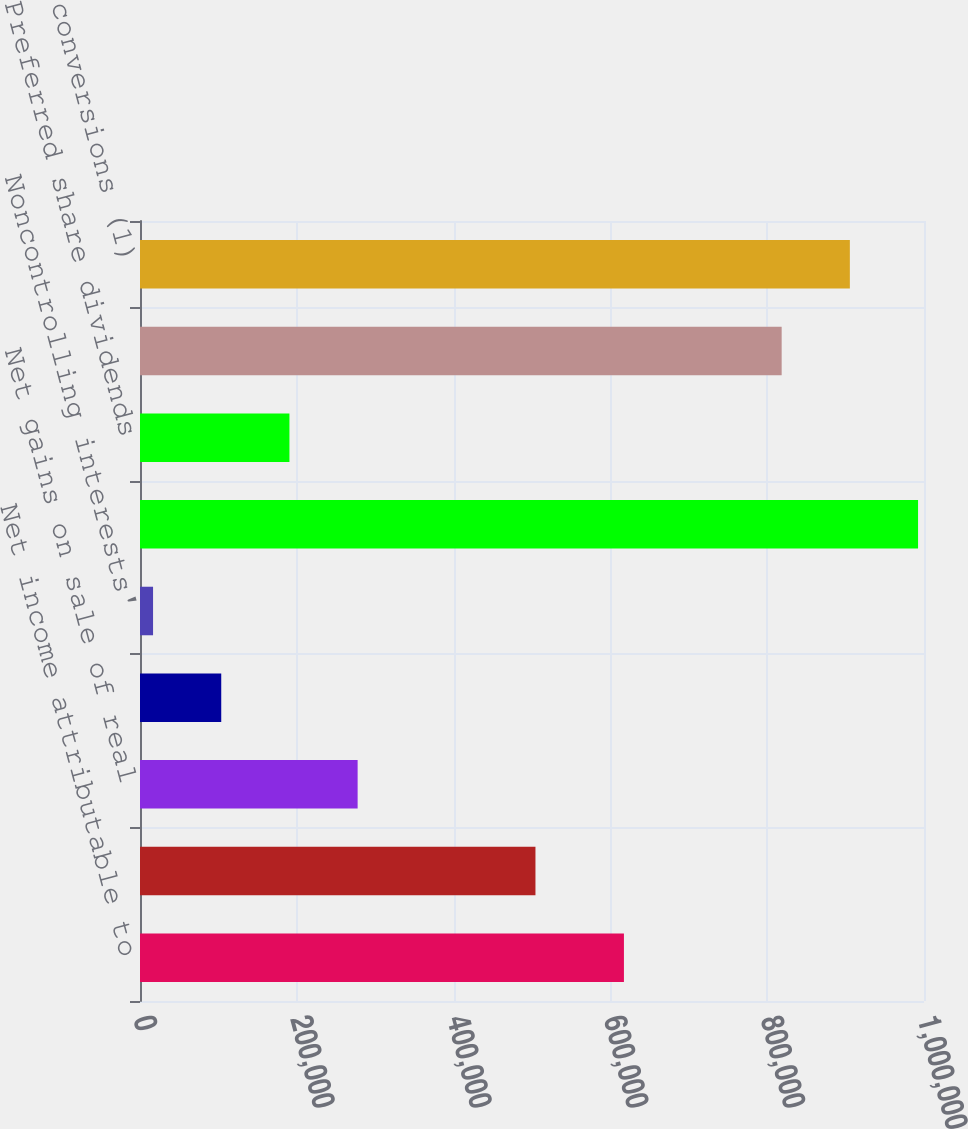<chart> <loc_0><loc_0><loc_500><loc_500><bar_chart><fcel>Net income attributable to<fcel>Depreciation and amortization<fcel>Net gains on sale of real<fcel>Income tax effect of above<fcel>Noncontrolling interests'<fcel>FFO<fcel>Preferred share dividends<fcel>FFO attributable to common<fcel>plus assumed conversions (1)<nl><fcel>617260<fcel>504407<fcel>277587<fcel>103628<fcel>16649<fcel>992410<fcel>190607<fcel>818452<fcel>905431<nl></chart> 